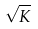Convert formula to latex. <formula><loc_0><loc_0><loc_500><loc_500>\sqrt { K }</formula> 